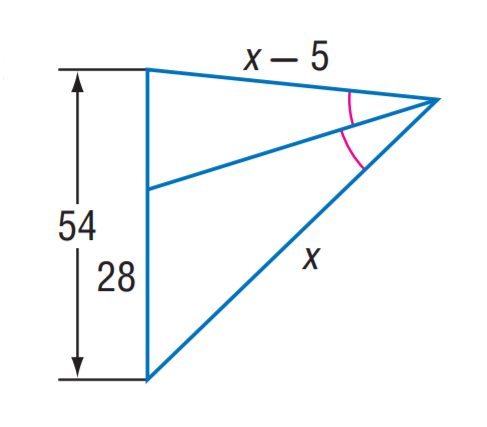Answer the mathemtical geometry problem and directly provide the correct option letter.
Question: Find x.
Choices: A: 42 B: 56 C: 70 D: 84 C 